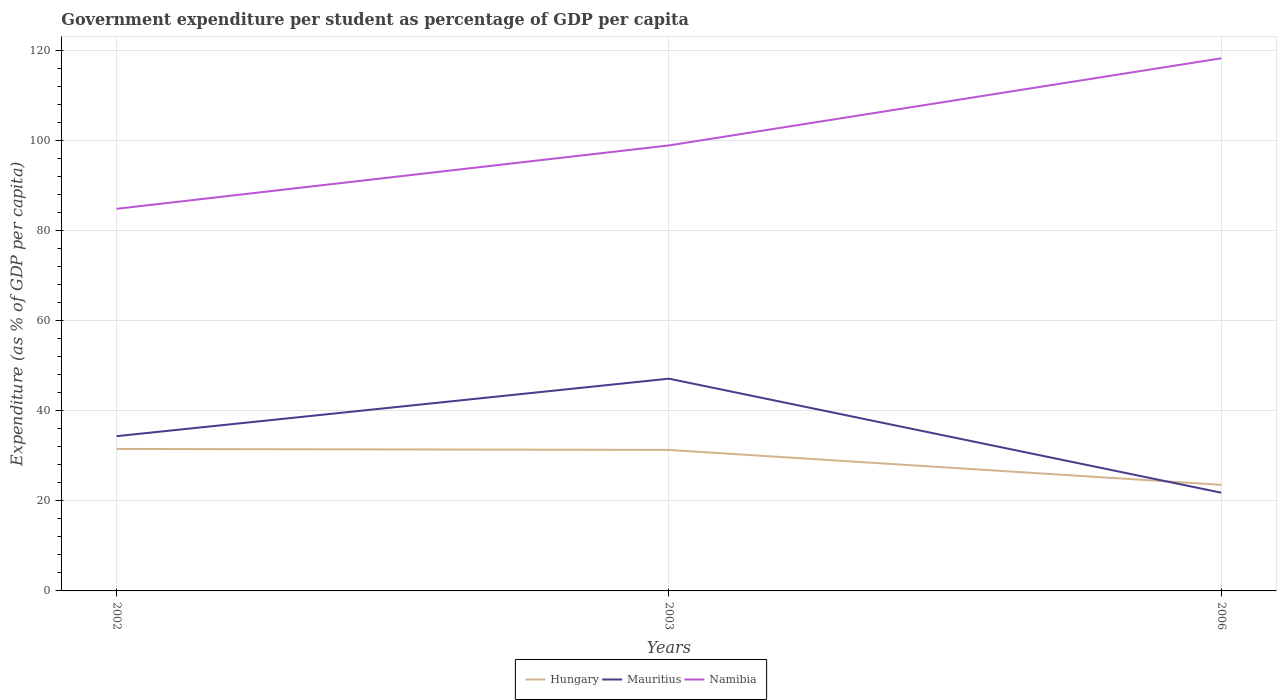Does the line corresponding to Mauritius intersect with the line corresponding to Hungary?
Offer a very short reply. Yes. Across all years, what is the maximum percentage of expenditure per student in Mauritius?
Ensure brevity in your answer.  21.8. What is the total percentage of expenditure per student in Mauritius in the graph?
Provide a succinct answer. 12.55. What is the difference between the highest and the second highest percentage of expenditure per student in Hungary?
Give a very brief answer. 7.97. What is the difference between the highest and the lowest percentage of expenditure per student in Namibia?
Make the answer very short. 1. How many years are there in the graph?
Provide a short and direct response. 3. What is the difference between two consecutive major ticks on the Y-axis?
Give a very brief answer. 20. How many legend labels are there?
Offer a terse response. 3. How are the legend labels stacked?
Give a very brief answer. Horizontal. What is the title of the graph?
Your response must be concise. Government expenditure per student as percentage of GDP per capita. Does "Spain" appear as one of the legend labels in the graph?
Your answer should be compact. No. What is the label or title of the X-axis?
Offer a terse response. Years. What is the label or title of the Y-axis?
Keep it short and to the point. Expenditure (as % of GDP per capita). What is the Expenditure (as % of GDP per capita) of Hungary in 2002?
Ensure brevity in your answer.  31.51. What is the Expenditure (as % of GDP per capita) in Mauritius in 2002?
Provide a short and direct response. 34.35. What is the Expenditure (as % of GDP per capita) of Namibia in 2002?
Give a very brief answer. 84.81. What is the Expenditure (as % of GDP per capita) of Hungary in 2003?
Your response must be concise. 31.29. What is the Expenditure (as % of GDP per capita) in Mauritius in 2003?
Give a very brief answer. 47.11. What is the Expenditure (as % of GDP per capita) in Namibia in 2003?
Provide a succinct answer. 98.88. What is the Expenditure (as % of GDP per capita) in Hungary in 2006?
Provide a succinct answer. 23.55. What is the Expenditure (as % of GDP per capita) in Mauritius in 2006?
Give a very brief answer. 21.8. What is the Expenditure (as % of GDP per capita) in Namibia in 2006?
Ensure brevity in your answer.  118.22. Across all years, what is the maximum Expenditure (as % of GDP per capita) of Hungary?
Your response must be concise. 31.51. Across all years, what is the maximum Expenditure (as % of GDP per capita) in Mauritius?
Make the answer very short. 47.11. Across all years, what is the maximum Expenditure (as % of GDP per capita) of Namibia?
Provide a succinct answer. 118.22. Across all years, what is the minimum Expenditure (as % of GDP per capita) of Hungary?
Your response must be concise. 23.55. Across all years, what is the minimum Expenditure (as % of GDP per capita) of Mauritius?
Offer a very short reply. 21.8. Across all years, what is the minimum Expenditure (as % of GDP per capita) of Namibia?
Make the answer very short. 84.81. What is the total Expenditure (as % of GDP per capita) of Hungary in the graph?
Your answer should be compact. 86.35. What is the total Expenditure (as % of GDP per capita) in Mauritius in the graph?
Provide a succinct answer. 103.26. What is the total Expenditure (as % of GDP per capita) of Namibia in the graph?
Your response must be concise. 301.9. What is the difference between the Expenditure (as % of GDP per capita) in Hungary in 2002 and that in 2003?
Your answer should be compact. 0.22. What is the difference between the Expenditure (as % of GDP per capita) in Mauritius in 2002 and that in 2003?
Keep it short and to the point. -12.76. What is the difference between the Expenditure (as % of GDP per capita) of Namibia in 2002 and that in 2003?
Offer a terse response. -14.07. What is the difference between the Expenditure (as % of GDP per capita) in Hungary in 2002 and that in 2006?
Your answer should be compact. 7.97. What is the difference between the Expenditure (as % of GDP per capita) in Mauritius in 2002 and that in 2006?
Provide a succinct answer. 12.55. What is the difference between the Expenditure (as % of GDP per capita) of Namibia in 2002 and that in 2006?
Your answer should be very brief. -33.41. What is the difference between the Expenditure (as % of GDP per capita) of Hungary in 2003 and that in 2006?
Your answer should be compact. 7.75. What is the difference between the Expenditure (as % of GDP per capita) in Mauritius in 2003 and that in 2006?
Give a very brief answer. 25.31. What is the difference between the Expenditure (as % of GDP per capita) in Namibia in 2003 and that in 2006?
Offer a very short reply. -19.34. What is the difference between the Expenditure (as % of GDP per capita) in Hungary in 2002 and the Expenditure (as % of GDP per capita) in Mauritius in 2003?
Offer a terse response. -15.59. What is the difference between the Expenditure (as % of GDP per capita) of Hungary in 2002 and the Expenditure (as % of GDP per capita) of Namibia in 2003?
Your answer should be very brief. -67.36. What is the difference between the Expenditure (as % of GDP per capita) in Mauritius in 2002 and the Expenditure (as % of GDP per capita) in Namibia in 2003?
Your answer should be compact. -64.53. What is the difference between the Expenditure (as % of GDP per capita) of Hungary in 2002 and the Expenditure (as % of GDP per capita) of Mauritius in 2006?
Your response must be concise. 9.71. What is the difference between the Expenditure (as % of GDP per capita) of Hungary in 2002 and the Expenditure (as % of GDP per capita) of Namibia in 2006?
Give a very brief answer. -86.7. What is the difference between the Expenditure (as % of GDP per capita) of Mauritius in 2002 and the Expenditure (as % of GDP per capita) of Namibia in 2006?
Ensure brevity in your answer.  -83.87. What is the difference between the Expenditure (as % of GDP per capita) in Hungary in 2003 and the Expenditure (as % of GDP per capita) in Mauritius in 2006?
Your response must be concise. 9.49. What is the difference between the Expenditure (as % of GDP per capita) in Hungary in 2003 and the Expenditure (as % of GDP per capita) in Namibia in 2006?
Your response must be concise. -86.92. What is the difference between the Expenditure (as % of GDP per capita) of Mauritius in 2003 and the Expenditure (as % of GDP per capita) of Namibia in 2006?
Offer a very short reply. -71.11. What is the average Expenditure (as % of GDP per capita) in Hungary per year?
Offer a terse response. 28.78. What is the average Expenditure (as % of GDP per capita) in Mauritius per year?
Keep it short and to the point. 34.42. What is the average Expenditure (as % of GDP per capita) of Namibia per year?
Provide a succinct answer. 100.63. In the year 2002, what is the difference between the Expenditure (as % of GDP per capita) of Hungary and Expenditure (as % of GDP per capita) of Mauritius?
Ensure brevity in your answer.  -2.84. In the year 2002, what is the difference between the Expenditure (as % of GDP per capita) in Hungary and Expenditure (as % of GDP per capita) in Namibia?
Offer a very short reply. -53.29. In the year 2002, what is the difference between the Expenditure (as % of GDP per capita) in Mauritius and Expenditure (as % of GDP per capita) in Namibia?
Offer a terse response. -50.46. In the year 2003, what is the difference between the Expenditure (as % of GDP per capita) in Hungary and Expenditure (as % of GDP per capita) in Mauritius?
Offer a very short reply. -15.82. In the year 2003, what is the difference between the Expenditure (as % of GDP per capita) of Hungary and Expenditure (as % of GDP per capita) of Namibia?
Offer a very short reply. -67.59. In the year 2003, what is the difference between the Expenditure (as % of GDP per capita) in Mauritius and Expenditure (as % of GDP per capita) in Namibia?
Give a very brief answer. -51.77. In the year 2006, what is the difference between the Expenditure (as % of GDP per capita) in Hungary and Expenditure (as % of GDP per capita) in Mauritius?
Provide a succinct answer. 1.75. In the year 2006, what is the difference between the Expenditure (as % of GDP per capita) in Hungary and Expenditure (as % of GDP per capita) in Namibia?
Your response must be concise. -94.67. In the year 2006, what is the difference between the Expenditure (as % of GDP per capita) of Mauritius and Expenditure (as % of GDP per capita) of Namibia?
Make the answer very short. -96.42. What is the ratio of the Expenditure (as % of GDP per capita) of Hungary in 2002 to that in 2003?
Make the answer very short. 1.01. What is the ratio of the Expenditure (as % of GDP per capita) in Mauritius in 2002 to that in 2003?
Offer a terse response. 0.73. What is the ratio of the Expenditure (as % of GDP per capita) of Namibia in 2002 to that in 2003?
Make the answer very short. 0.86. What is the ratio of the Expenditure (as % of GDP per capita) in Hungary in 2002 to that in 2006?
Make the answer very short. 1.34. What is the ratio of the Expenditure (as % of GDP per capita) in Mauritius in 2002 to that in 2006?
Keep it short and to the point. 1.58. What is the ratio of the Expenditure (as % of GDP per capita) in Namibia in 2002 to that in 2006?
Your answer should be compact. 0.72. What is the ratio of the Expenditure (as % of GDP per capita) in Hungary in 2003 to that in 2006?
Offer a terse response. 1.33. What is the ratio of the Expenditure (as % of GDP per capita) in Mauritius in 2003 to that in 2006?
Your answer should be compact. 2.16. What is the ratio of the Expenditure (as % of GDP per capita) of Namibia in 2003 to that in 2006?
Give a very brief answer. 0.84. What is the difference between the highest and the second highest Expenditure (as % of GDP per capita) in Hungary?
Your answer should be very brief. 0.22. What is the difference between the highest and the second highest Expenditure (as % of GDP per capita) of Mauritius?
Offer a very short reply. 12.76. What is the difference between the highest and the second highest Expenditure (as % of GDP per capita) in Namibia?
Offer a terse response. 19.34. What is the difference between the highest and the lowest Expenditure (as % of GDP per capita) in Hungary?
Keep it short and to the point. 7.97. What is the difference between the highest and the lowest Expenditure (as % of GDP per capita) of Mauritius?
Your response must be concise. 25.31. What is the difference between the highest and the lowest Expenditure (as % of GDP per capita) of Namibia?
Provide a short and direct response. 33.41. 